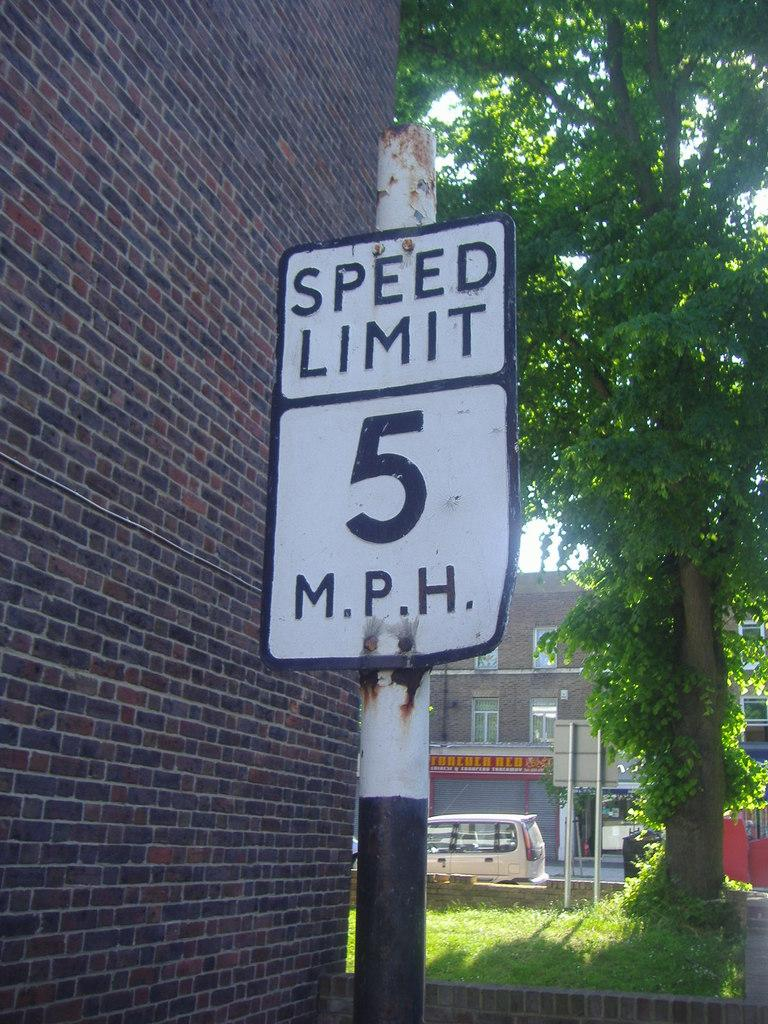What is the main object in the image? There is a white color board in the image. How is the color board positioned in the image? The board is attached to a pole. What can be seen in the background of the image? There are trees, vehicles, and buildings visible in the background. What is the color of the trees in the background? The trees are green in color. What is the color of the buildings in the background? The buildings are brown in color. What is visible in the sky in the image? The sky is visible in the image. What is the color of the sky in the image? The sky is white in color. Can you see an owl jumping from one tree to another in the image? There is no owl or jumping action present in the image. 